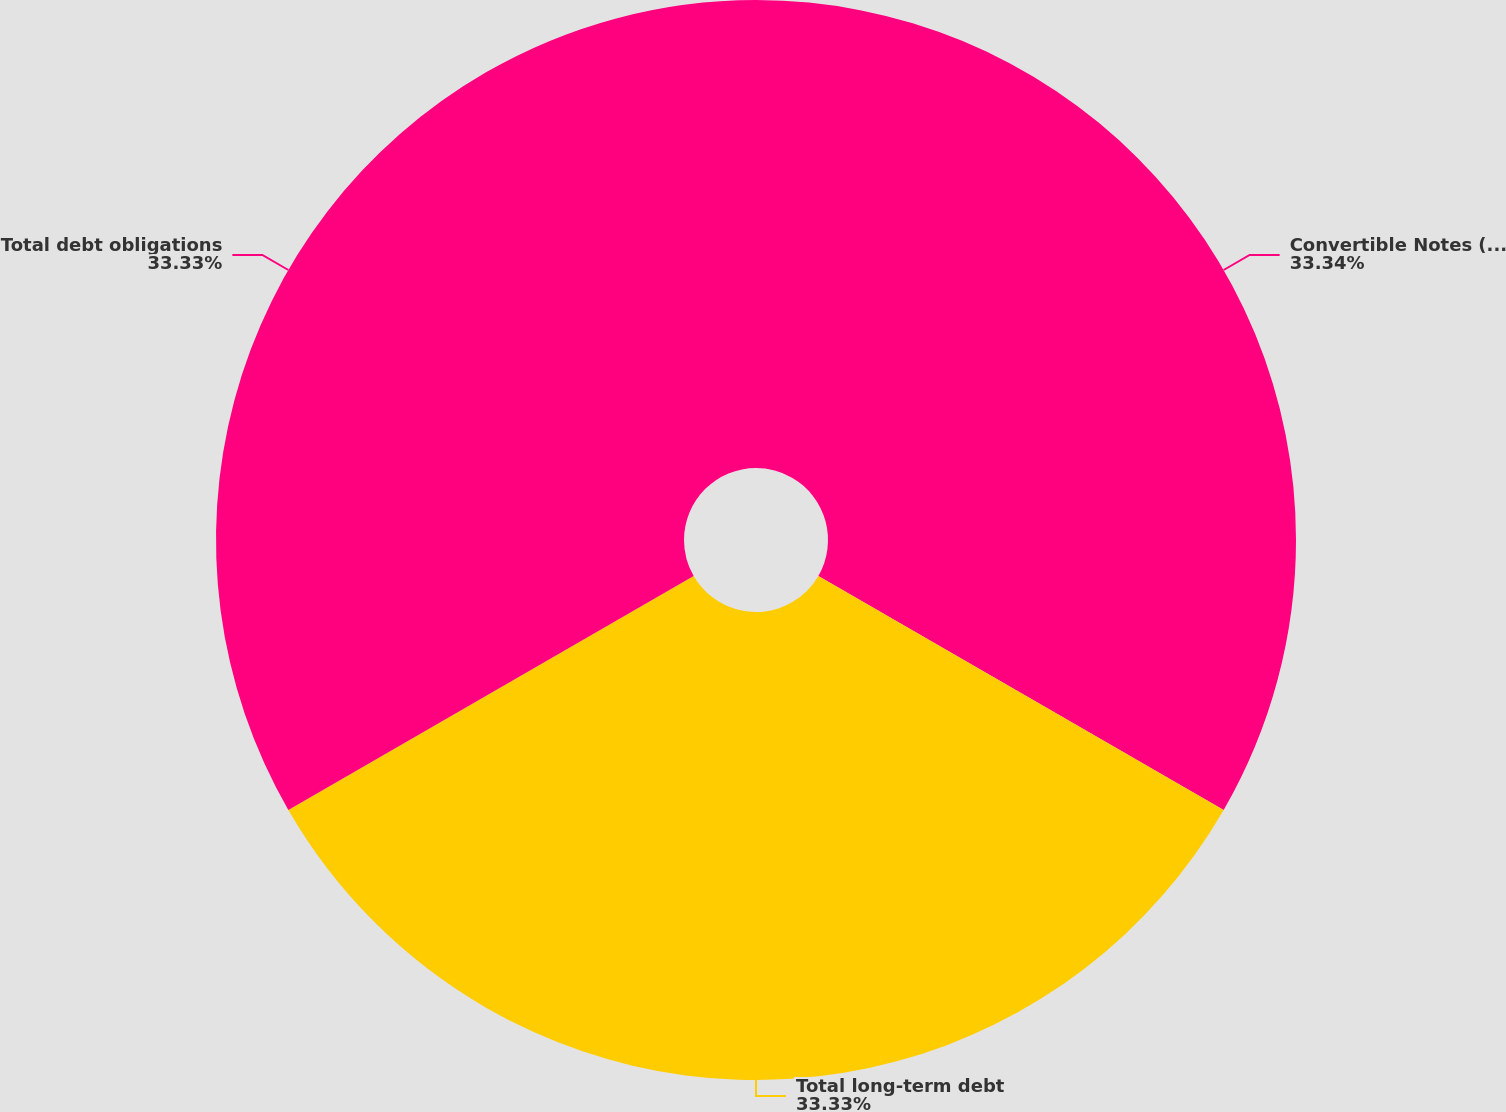Convert chart. <chart><loc_0><loc_0><loc_500><loc_500><pie_chart><fcel>Convertible Notes (principal<fcel>Total long-term debt<fcel>Total debt obligations<nl><fcel>33.33%<fcel>33.33%<fcel>33.33%<nl></chart> 